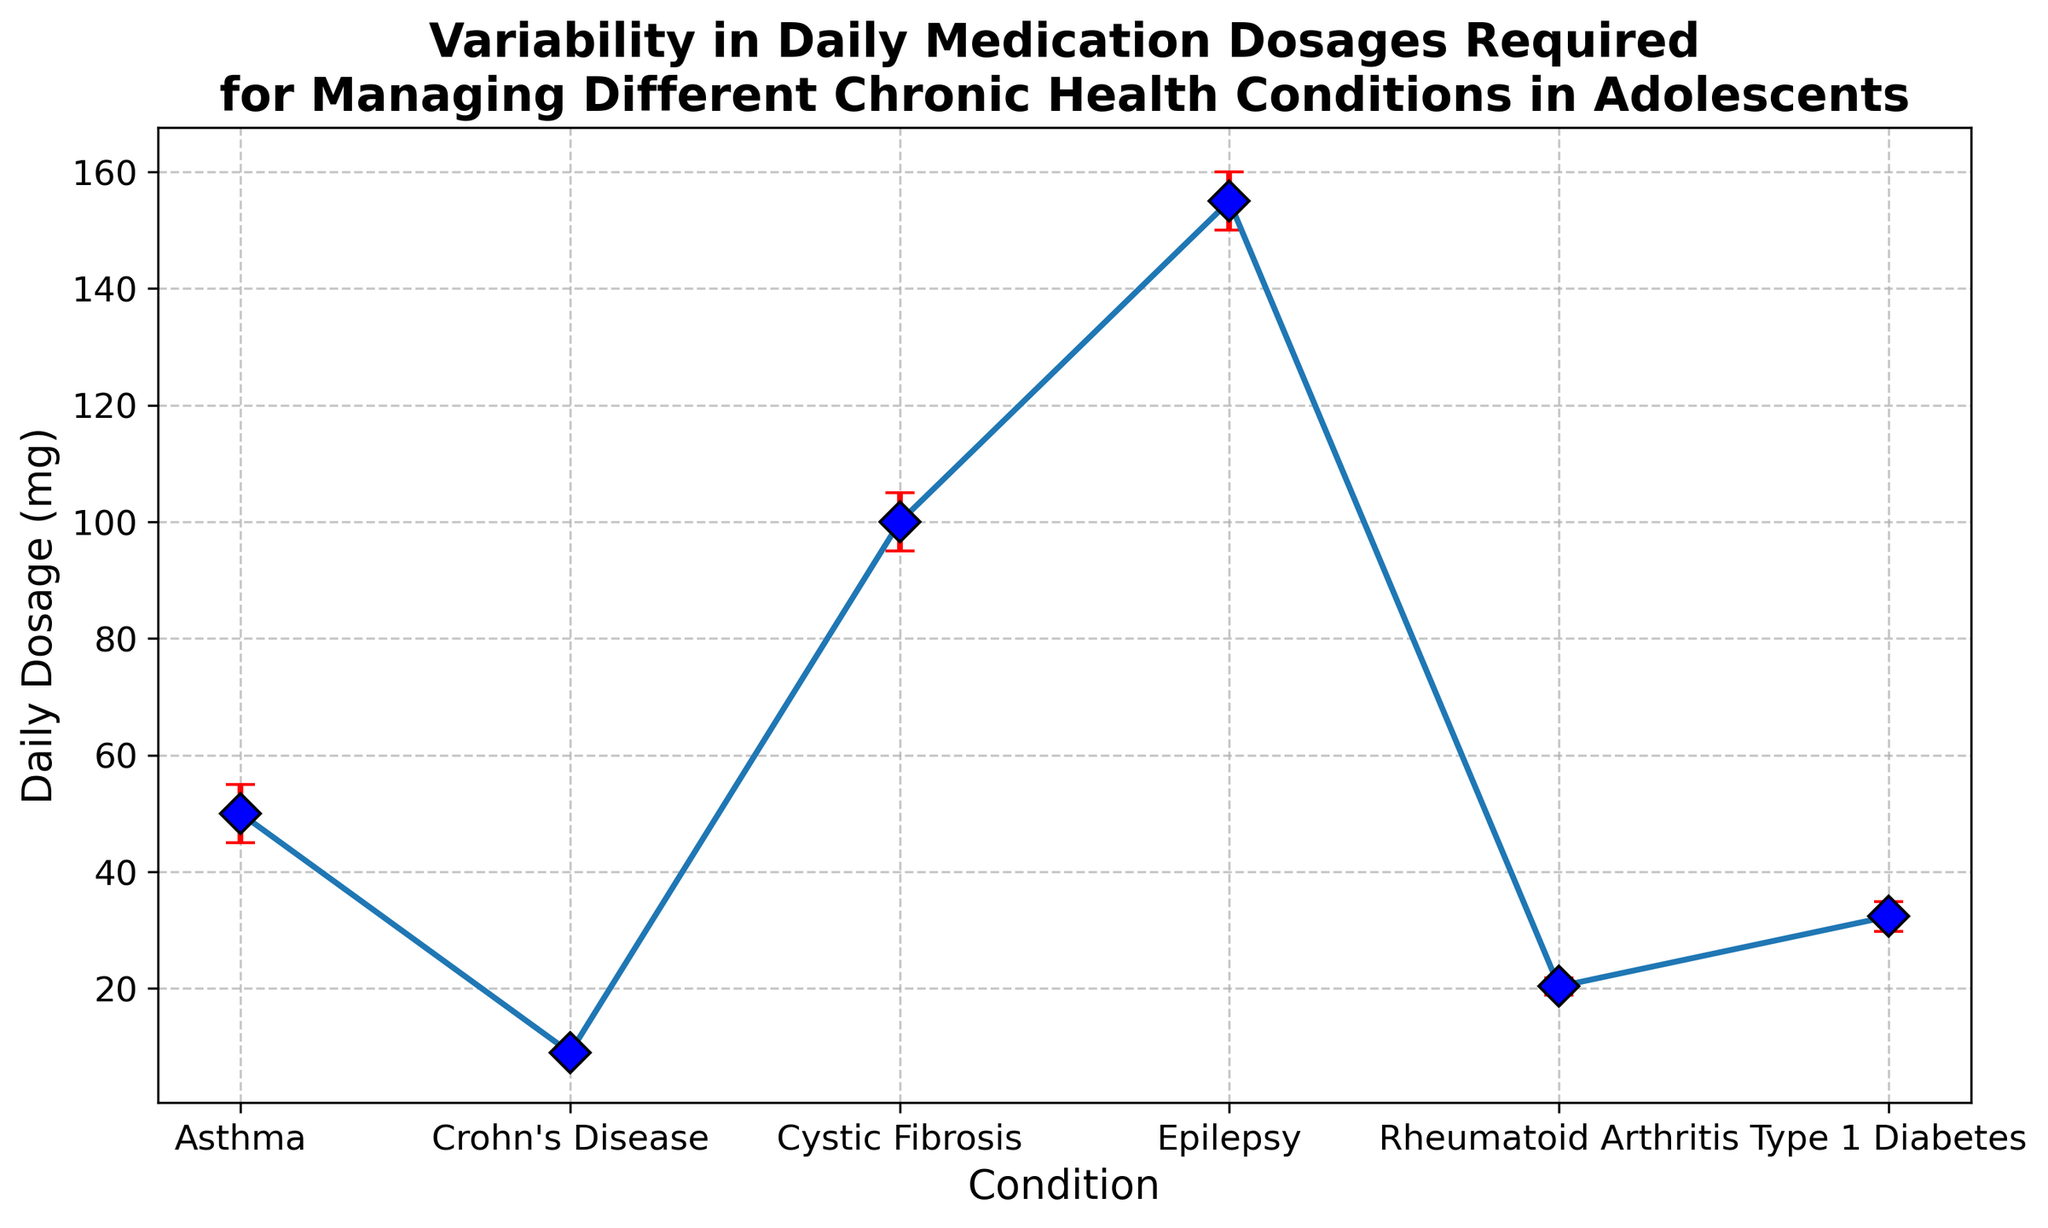Is the average daily dosage required for managing asthma higher or lower than for managing diabetes? First, locate the average daily dosage for both asthma and diabetes in the chart. For asthma, it’s around 50 mg, and for type 1 diabetes, it’s around 32 mg. Asthma's average dosage is higher than diabetes'.
Answer: Higher Which condition has the most variability in daily medication dosage? Check which condition has the largest error bars (red) in the chart. The condition with the biggest error bars is epilepsy, indicating it has the most variability.
Answer: Epilepsy What is the approximate range of daily dosage for managing epilepsy? Note the mean and the standard deviation for epilepsy (mean ~155 mg, std deviation ~22 mg). The range can be approximated as mean ± std deviation, giving roughly 133 mg to 177 mg.
Answer: 133 mg to 177 mg Comparing Crohn's Disease and Rheumatoid Arthritis, which condition has a higher average daily dosage? Look at the chart to find the mean daily dosages for Crohn's Disease (~9 mg) and Rheumatoid Arthritis (~20 mg). Rheumatoid Arthritis has the higher average dosage.
Answer: Rheumatoid Arthritis Which condition has the smallest standard deviation in their daily dosage? Check the lengths of the error bars for different conditions in the chart. Crohn's Disease has the smallest error bars, indicating the smallest standard deviation.
Answer: Crohn’s Disease Does Cystic Fibrosis have a higher average daily dosage than Rheumatoid Arthritis? Refer to the average daily dosages shown in the chart. For Cystic Fibrosis, it's around 100 mg, and for Rheumatoid Arthritis, it’s around 20 mg. Cystic Fibrosis has a higher average dosage.
Answer: Yes What is the total of the average daily dosages for Asthma and Cystic Fibrosis? Sum the average daily dosages for Asthma (50 mg) and Cystic Fibrosis (100 mg). 50 + 100 = 150 mg.
Answer: 150 mg Which two conditions have the closest average daily dosages? Compare the average daily dosages for all conditions visually. The averages for Crohn's Disease (~9 mg) and Rheumatoid Arthritis (~20 mg) are quite different. The closest averages are for Asthma (~50 mg) and Cystic Fibrosis (~100 mg) as they display the smallest discrepancy in means.
Answer: Asthma and Cystic Fibrosis Does Type 1 Diabetes have more variability in daily dosage than Crohn's Disease? Compare the error bar lengths for Type 1 Diabetes and Crohn's Disease. Type 1 Diabetes has larger error bars (~6 mg) compared to Crohn's Disease (~2 mg), indicating more variability.
Answer: Yes 